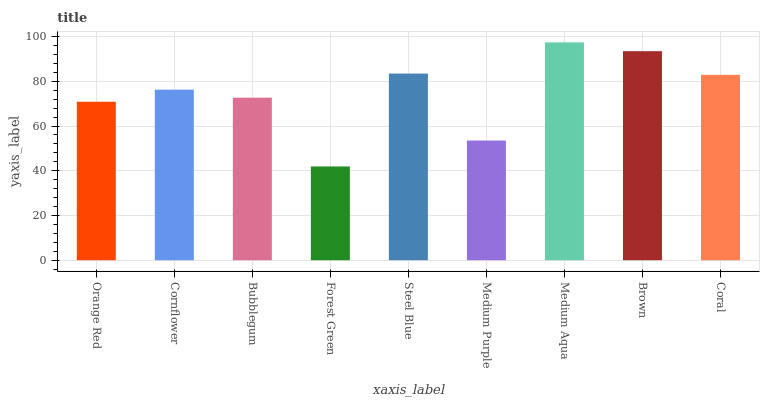Is Forest Green the minimum?
Answer yes or no. Yes. Is Medium Aqua the maximum?
Answer yes or no. Yes. Is Cornflower the minimum?
Answer yes or no. No. Is Cornflower the maximum?
Answer yes or no. No. Is Cornflower greater than Orange Red?
Answer yes or no. Yes. Is Orange Red less than Cornflower?
Answer yes or no. Yes. Is Orange Red greater than Cornflower?
Answer yes or no. No. Is Cornflower less than Orange Red?
Answer yes or no. No. Is Cornflower the high median?
Answer yes or no. Yes. Is Cornflower the low median?
Answer yes or no. Yes. Is Coral the high median?
Answer yes or no. No. Is Steel Blue the low median?
Answer yes or no. No. 